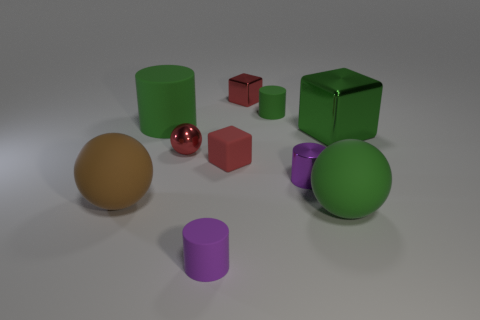Subtract all tiny balls. How many balls are left? 2 Subtract all cubes. How many objects are left? 7 Subtract all green cylinders. How many cylinders are left? 2 Subtract 3 spheres. How many spheres are left? 0 Subtract all small red metal things. Subtract all green cubes. How many objects are left? 7 Add 1 big metallic things. How many big metallic things are left? 2 Add 8 small cyan shiny blocks. How many small cyan shiny blocks exist? 8 Subtract 0 brown cylinders. How many objects are left? 10 Subtract all red cubes. Subtract all brown spheres. How many cubes are left? 1 Subtract all purple spheres. How many purple cylinders are left? 2 